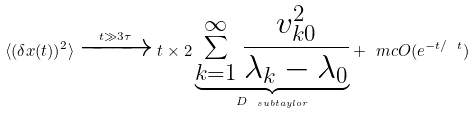Convert formula to latex. <formula><loc_0><loc_0><loc_500><loc_500>\langle ( \delta x ( t ) ) ^ { 2 } \rangle \xrightarrow { t \gg 3 \tau } t \times 2 \underbrace { \sum _ { k = 1 } ^ { \infty } \frac { v _ { k 0 } ^ { 2 } } { \lambda _ { k } - \lambda _ { 0 } } } _ { D _ { \ s u b { t a y l o r } } } + \ m c { O } ( e ^ { - t / \ t } )</formula> 